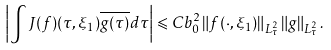<formula> <loc_0><loc_0><loc_500><loc_500>\left | \int J ( f ) ( \tau , \xi _ { 1 } ) \overline { g ( \tau ) } d \tau \right | \leqslant C b _ { 0 } ^ { 2 } \left \| f ( \cdot , \xi _ { 1 } ) \right \| _ { L _ { \tau } ^ { 2 } } \left \| g \right \| _ { L _ { \tau } ^ { 2 } } .</formula> 